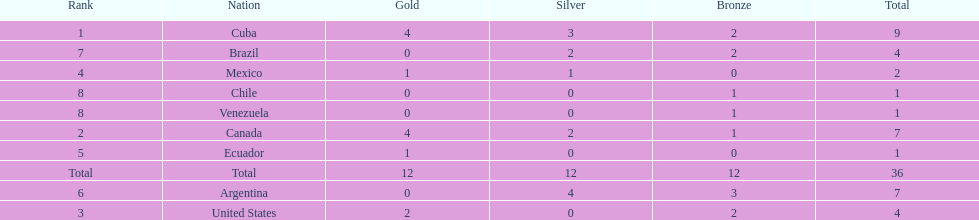Would you be able to parse every entry in this table? {'header': ['Rank', 'Nation', 'Gold', 'Silver', 'Bronze', 'Total'], 'rows': [['1', 'Cuba', '4', '3', '2', '9'], ['7', 'Brazil', '0', '2', '2', '4'], ['4', 'Mexico', '1', '1', '0', '2'], ['8', 'Chile', '0', '0', '1', '1'], ['8', 'Venezuela', '0', '0', '1', '1'], ['2', 'Canada', '4', '2', '1', '7'], ['5', 'Ecuador', '1', '0', '0', '1'], ['Total', 'Total', '12', '12', '12', '36'], ['6', 'Argentina', '0', '4', '3', '7'], ['3', 'United States', '2', '0', '2', '4']]} Which is the only nation to win a gold medal and nothing else? Ecuador. 